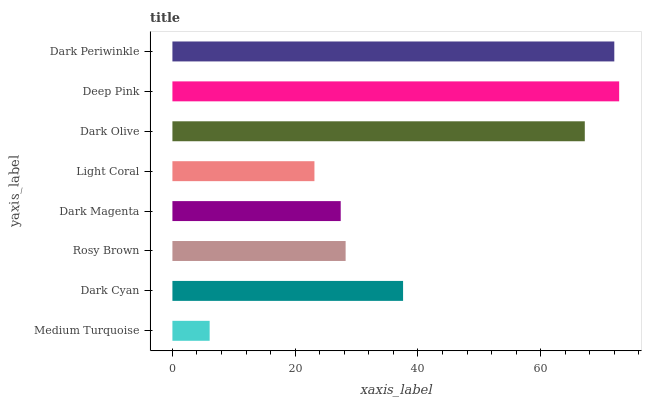Is Medium Turquoise the minimum?
Answer yes or no. Yes. Is Deep Pink the maximum?
Answer yes or no. Yes. Is Dark Cyan the minimum?
Answer yes or no. No. Is Dark Cyan the maximum?
Answer yes or no. No. Is Dark Cyan greater than Medium Turquoise?
Answer yes or no. Yes. Is Medium Turquoise less than Dark Cyan?
Answer yes or no. Yes. Is Medium Turquoise greater than Dark Cyan?
Answer yes or no. No. Is Dark Cyan less than Medium Turquoise?
Answer yes or no. No. Is Dark Cyan the high median?
Answer yes or no. Yes. Is Rosy Brown the low median?
Answer yes or no. Yes. Is Dark Magenta the high median?
Answer yes or no. No. Is Dark Magenta the low median?
Answer yes or no. No. 